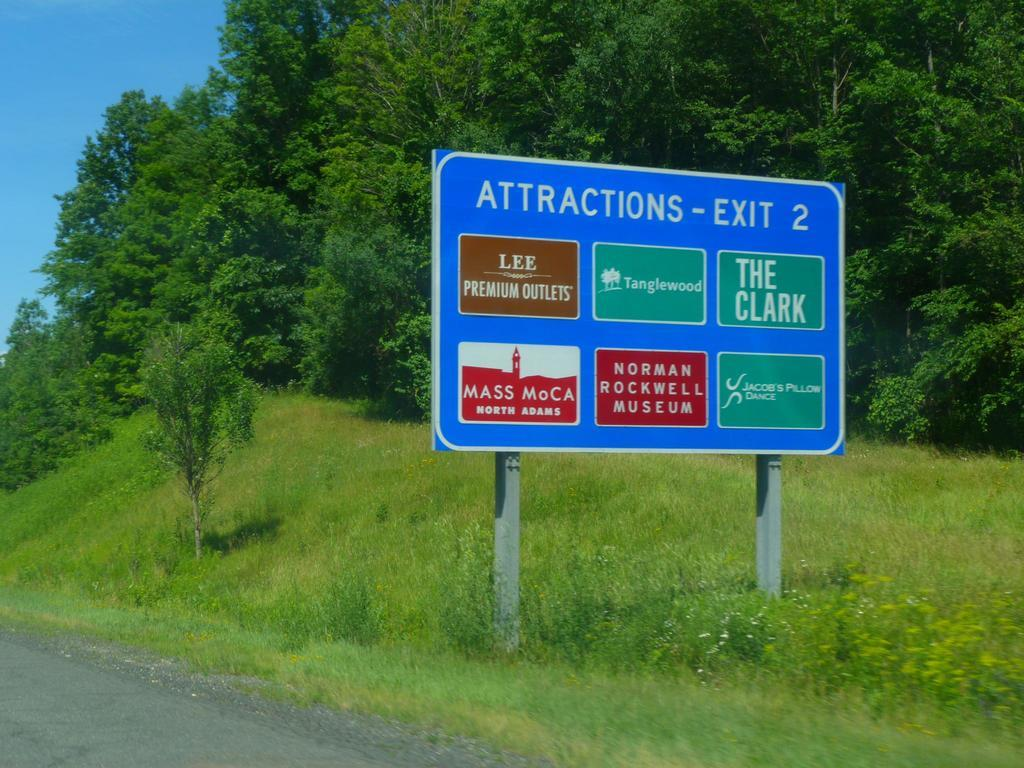<image>
Share a concise interpretation of the image provided. A large blue Attractions - Exit 2 road sign on the side of a road with a lot of greenery. 